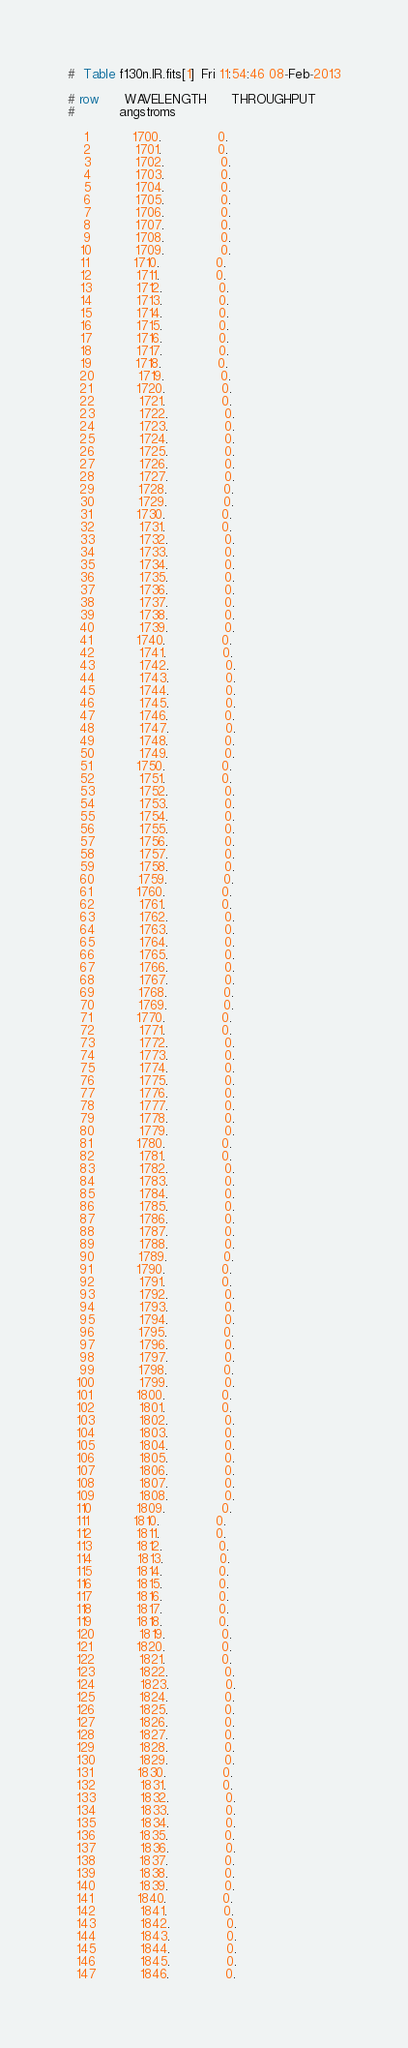<code> <loc_0><loc_0><loc_500><loc_500><_SQL_>#  Table f130n.IR.fits[1]  Fri 11:54:46 08-Feb-2013

# row      WAVELENGTH      THROUGHPUT
#           angstroms                

    1           1700.              0.
    2           1701.              0.
    3           1702.              0.
    4           1703.              0.
    5           1704.              0.
    6           1705.              0.
    7           1706.              0.
    8           1707.              0.
    9           1708.              0.
   10           1709.              0.
   11           1710.              0.
   12           1711.              0.
   13           1712.              0.
   14           1713.              0.
   15           1714.              0.
   16           1715.              0.
   17           1716.              0.
   18           1717.              0.
   19           1718.              0.
   20           1719.              0.
   21           1720.              0.
   22           1721.              0.
   23           1722.              0.
   24           1723.              0.
   25           1724.              0.
   26           1725.              0.
   27           1726.              0.
   28           1727.              0.
   29           1728.              0.
   30           1729.              0.
   31           1730.              0.
   32           1731.              0.
   33           1732.              0.
   34           1733.              0.
   35           1734.              0.
   36           1735.              0.
   37           1736.              0.
   38           1737.              0.
   39           1738.              0.
   40           1739.              0.
   41           1740.              0.
   42           1741.              0.
   43           1742.              0.
   44           1743.              0.
   45           1744.              0.
   46           1745.              0.
   47           1746.              0.
   48           1747.              0.
   49           1748.              0.
   50           1749.              0.
   51           1750.              0.
   52           1751.              0.
   53           1752.              0.
   54           1753.              0.
   55           1754.              0.
   56           1755.              0.
   57           1756.              0.
   58           1757.              0.
   59           1758.              0.
   60           1759.              0.
   61           1760.              0.
   62           1761.              0.
   63           1762.              0.
   64           1763.              0.
   65           1764.              0.
   66           1765.              0.
   67           1766.              0.
   68           1767.              0.
   69           1768.              0.
   70           1769.              0.
   71           1770.              0.
   72           1771.              0.
   73           1772.              0.
   74           1773.              0.
   75           1774.              0.
   76           1775.              0.
   77           1776.              0.
   78           1777.              0.
   79           1778.              0.
   80           1779.              0.
   81           1780.              0.
   82           1781.              0.
   83           1782.              0.
   84           1783.              0.
   85           1784.              0.
   86           1785.              0.
   87           1786.              0.
   88           1787.              0.
   89           1788.              0.
   90           1789.              0.
   91           1790.              0.
   92           1791.              0.
   93           1792.              0.
   94           1793.              0.
   95           1794.              0.
   96           1795.              0.
   97           1796.              0.
   98           1797.              0.
   99           1798.              0.
  100           1799.              0.
  101           1800.              0.
  102           1801.              0.
  103           1802.              0.
  104           1803.              0.
  105           1804.              0.
  106           1805.              0.
  107           1806.              0.
  108           1807.              0.
  109           1808.              0.
  110           1809.              0.
  111           1810.              0.
  112           1811.              0.
  113           1812.              0.
  114           1813.              0.
  115           1814.              0.
  116           1815.              0.
  117           1816.              0.
  118           1817.              0.
  119           1818.              0.
  120           1819.              0.
  121           1820.              0.
  122           1821.              0.
  123           1822.              0.
  124           1823.              0.
  125           1824.              0.
  126           1825.              0.
  127           1826.              0.
  128           1827.              0.
  129           1828.              0.
  130           1829.              0.
  131           1830.              0.
  132           1831.              0.
  133           1832.              0.
  134           1833.              0.
  135           1834.              0.
  136           1835.              0.
  137           1836.              0.
  138           1837.              0.
  139           1838.              0.
  140           1839.              0.
  141           1840.              0.
  142           1841.              0.
  143           1842.              0.
  144           1843.              0.
  145           1844.              0.
  146           1845.              0.
  147           1846.              0.</code> 